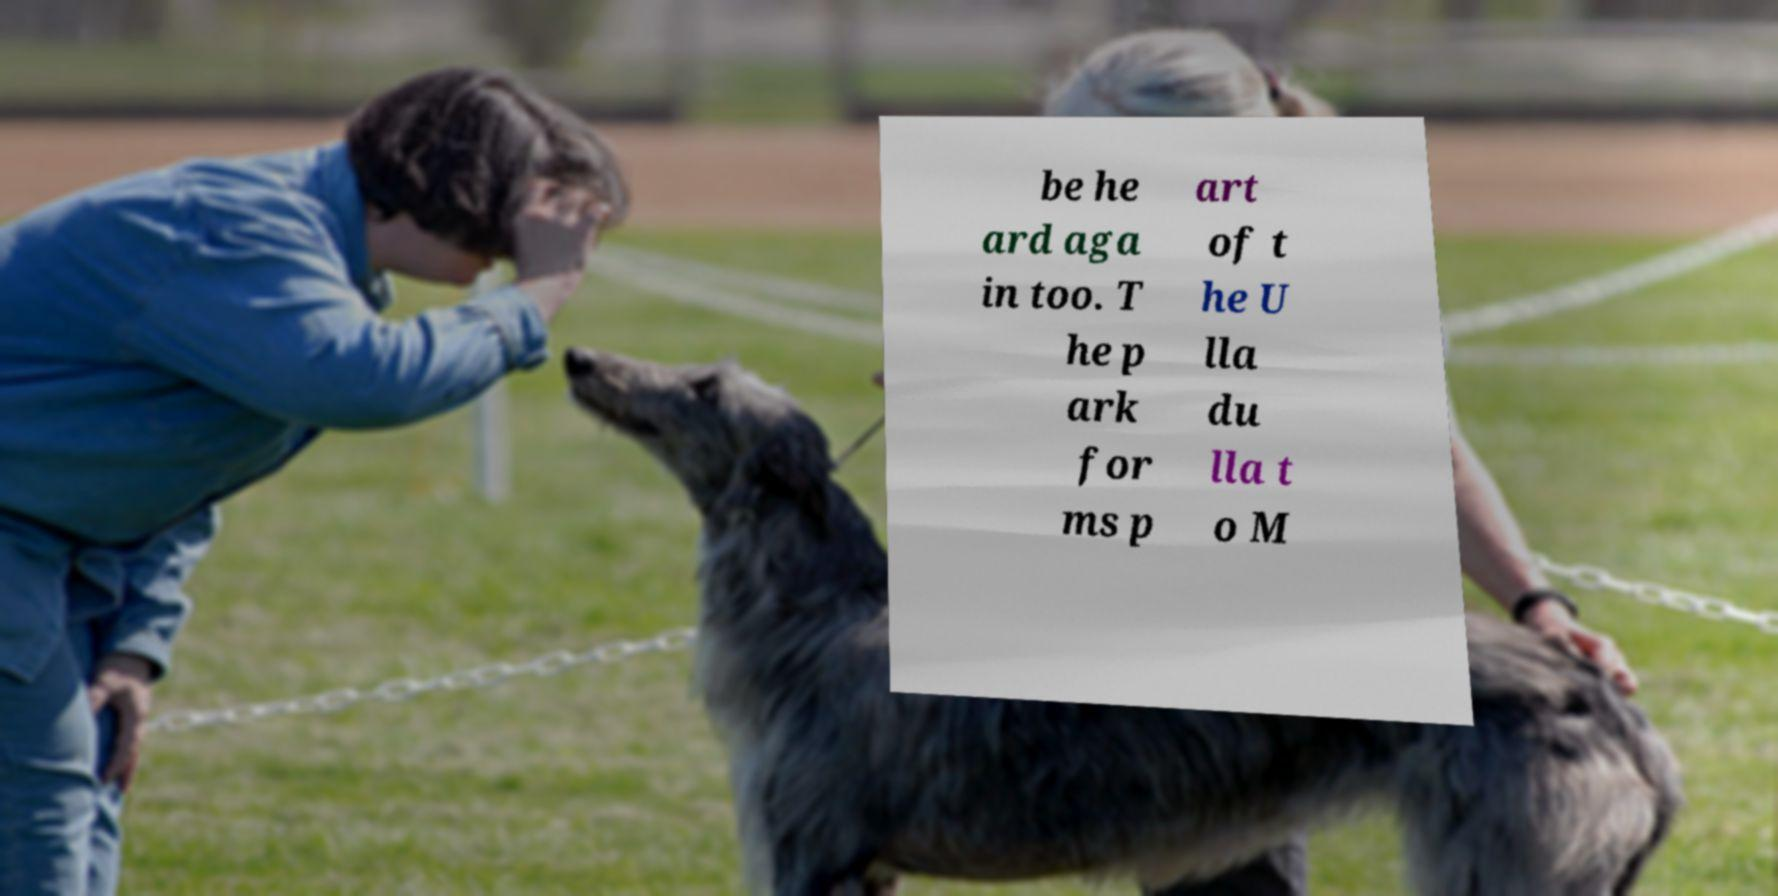I need the written content from this picture converted into text. Can you do that? be he ard aga in too. T he p ark for ms p art of t he U lla du lla t o M 